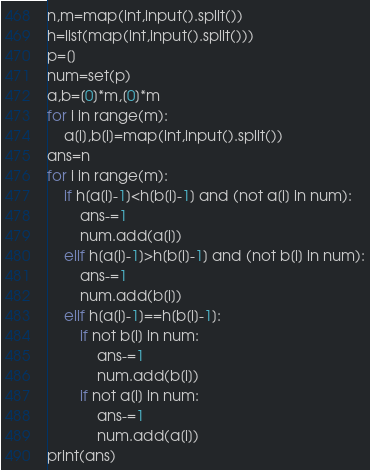<code> <loc_0><loc_0><loc_500><loc_500><_Python_>n,m=map(int,input().split())
h=list(map(int,input().split()))
p=[]
num=set(p)
a,b=[0]*m,[0]*m
for i in range(m):
    a[i],b[i]=map(int,input().split())
ans=n
for i in range(m):
    if h[a[i]-1]<h[b[i]-1] and (not a[i] in num):
        ans-=1
        num.add(a[i])
    elif h[a[i]-1]>h[b[i]-1] and (not b[i] in num):
        ans-=1
        num.add(b[i])
    elif h[a[i]-1]==h[b[i]-1]:
        if not b[i] in num:
            ans-=1
            num.add(b[i])
        if not a[i] in num:
            ans-=1
            num.add(a[i])
print(ans)
</code> 